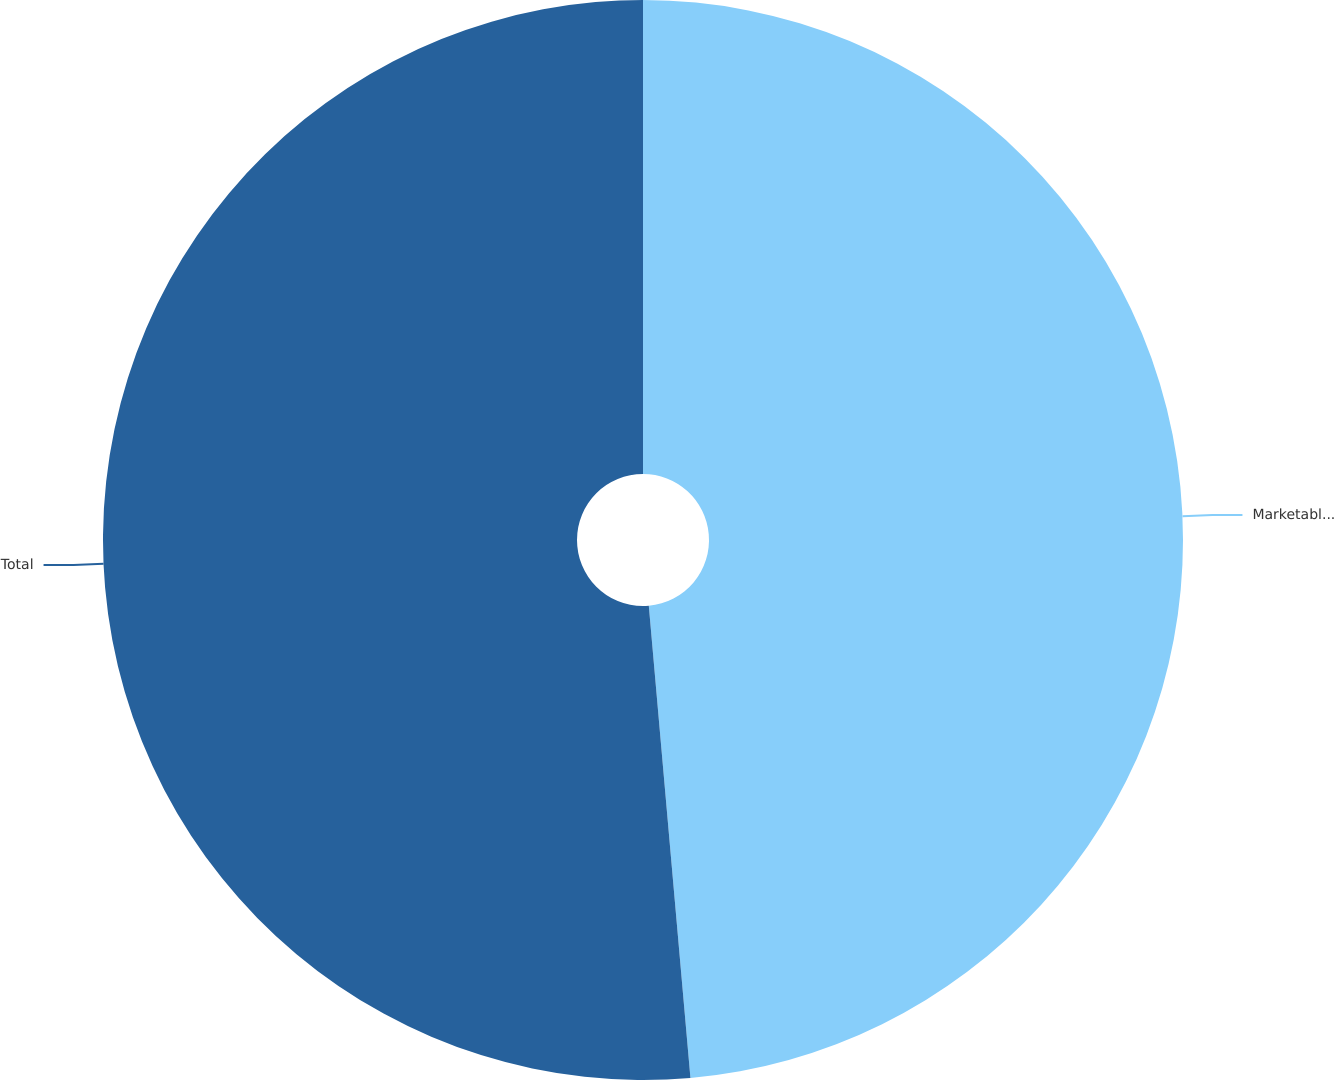Convert chart. <chart><loc_0><loc_0><loc_500><loc_500><pie_chart><fcel>Marketable securities<fcel>Total<nl><fcel>48.6%<fcel>51.4%<nl></chart> 